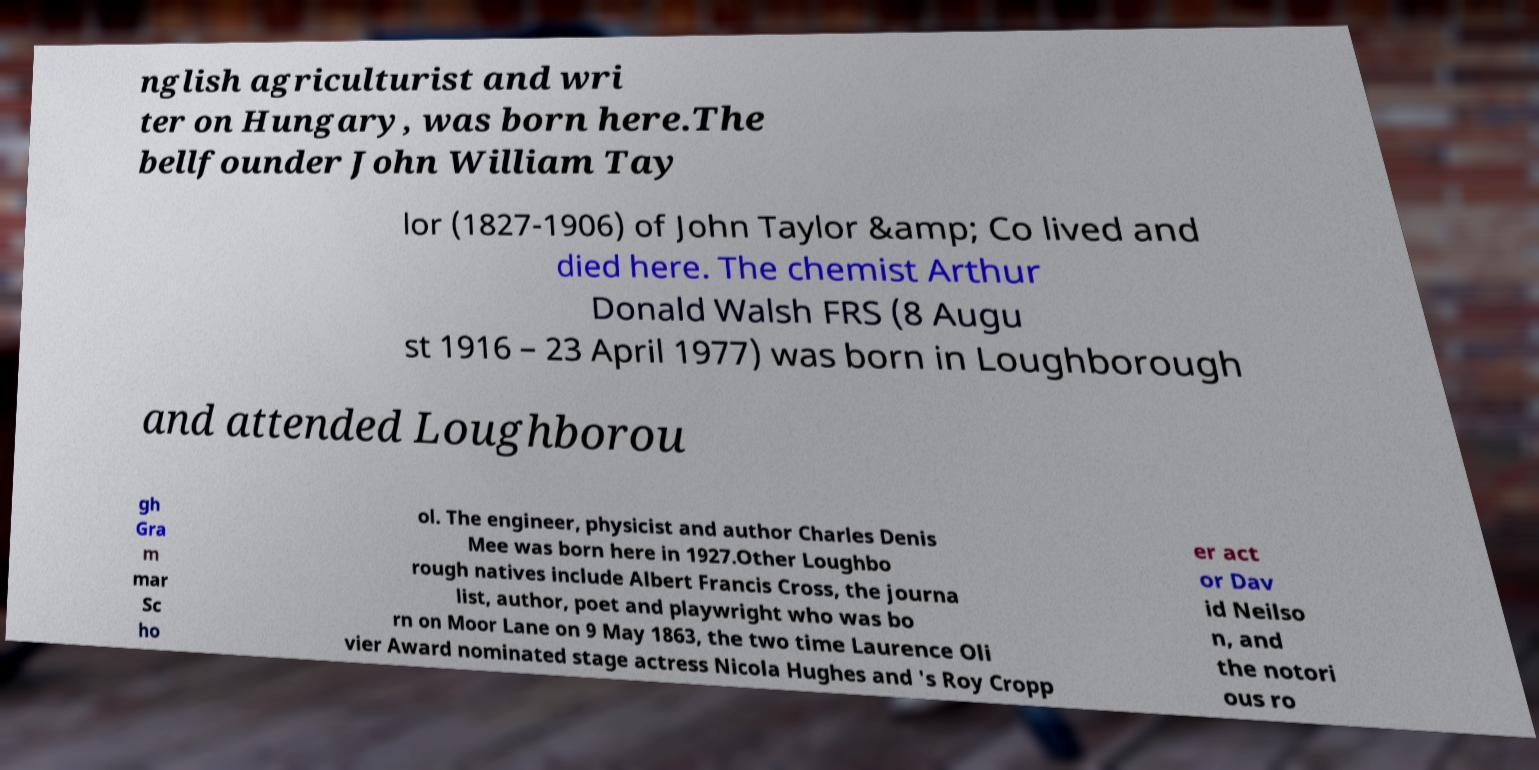What messages or text are displayed in this image? I need them in a readable, typed format. nglish agriculturist and wri ter on Hungary, was born here.The bellfounder John William Tay lor (1827-1906) of John Taylor &amp; Co lived and died here. The chemist Arthur Donald Walsh FRS (8 Augu st 1916 – 23 April 1977) was born in Loughborough and attended Loughborou gh Gra m mar Sc ho ol. The engineer, physicist and author Charles Denis Mee was born here in 1927.Other Loughbo rough natives include Albert Francis Cross, the journa list, author, poet and playwright who was bo rn on Moor Lane on 9 May 1863, the two time Laurence Oli vier Award nominated stage actress Nicola Hughes and 's Roy Cropp er act or Dav id Neilso n, and the notori ous ro 